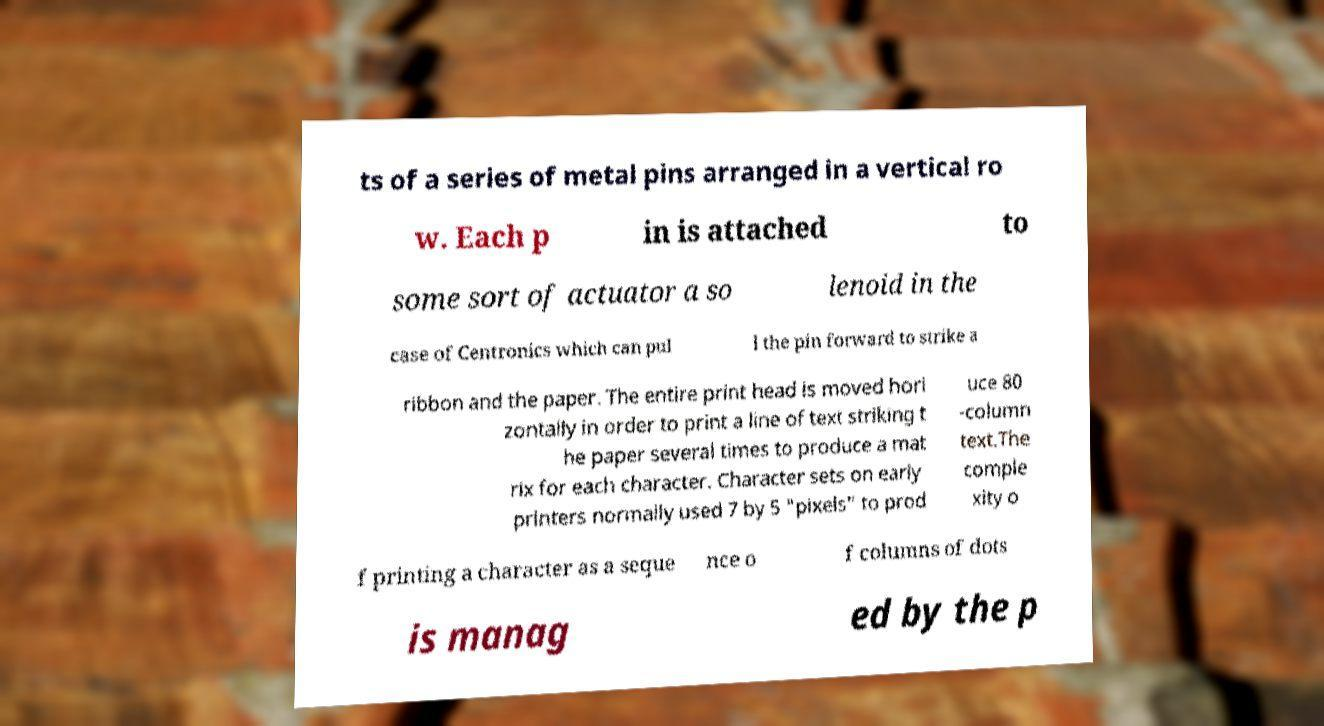Could you extract and type out the text from this image? ts of a series of metal pins arranged in a vertical ro w. Each p in is attached to some sort of actuator a so lenoid in the case of Centronics which can pul l the pin forward to strike a ribbon and the paper. The entire print head is moved hori zontally in order to print a line of text striking t he paper several times to produce a mat rix for each character. Character sets on early printers normally used 7 by 5 "pixels" to prod uce 80 -column text.The comple xity o f printing a character as a seque nce o f columns of dots is manag ed by the p 